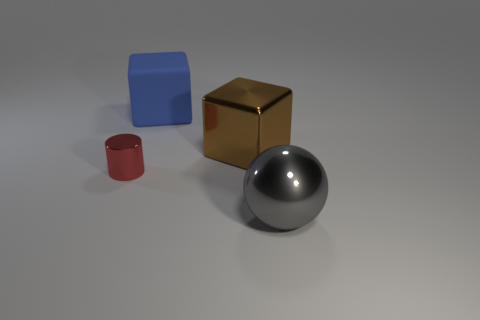Add 4 gray balls. How many objects exist? 8 Subtract all blue blocks. How many blocks are left? 1 Subtract 1 blocks. How many blocks are left? 1 Subtract all balls. How many objects are left? 3 Subtract all yellow blocks. How many brown cylinders are left? 0 Subtract all small red metal cubes. Subtract all small metallic objects. How many objects are left? 3 Add 2 large metal balls. How many large metal balls are left? 3 Add 3 big gray metal things. How many big gray metal things exist? 4 Subtract 0 yellow cubes. How many objects are left? 4 Subtract all red cubes. Subtract all blue balls. How many cubes are left? 2 